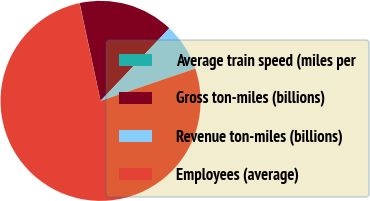Convert chart to OTSL. <chart><loc_0><loc_0><loc_500><loc_500><pie_chart><fcel>Average train speed (miles per<fcel>Gross ton-miles (billions)<fcel>Revenue ton-miles (billions)<fcel>Employees (average)<nl><fcel>0.04%<fcel>15.4%<fcel>7.72%<fcel>76.83%<nl></chart> 